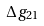Convert formula to latex. <formula><loc_0><loc_0><loc_500><loc_500>\Delta g _ { 2 1 }</formula> 